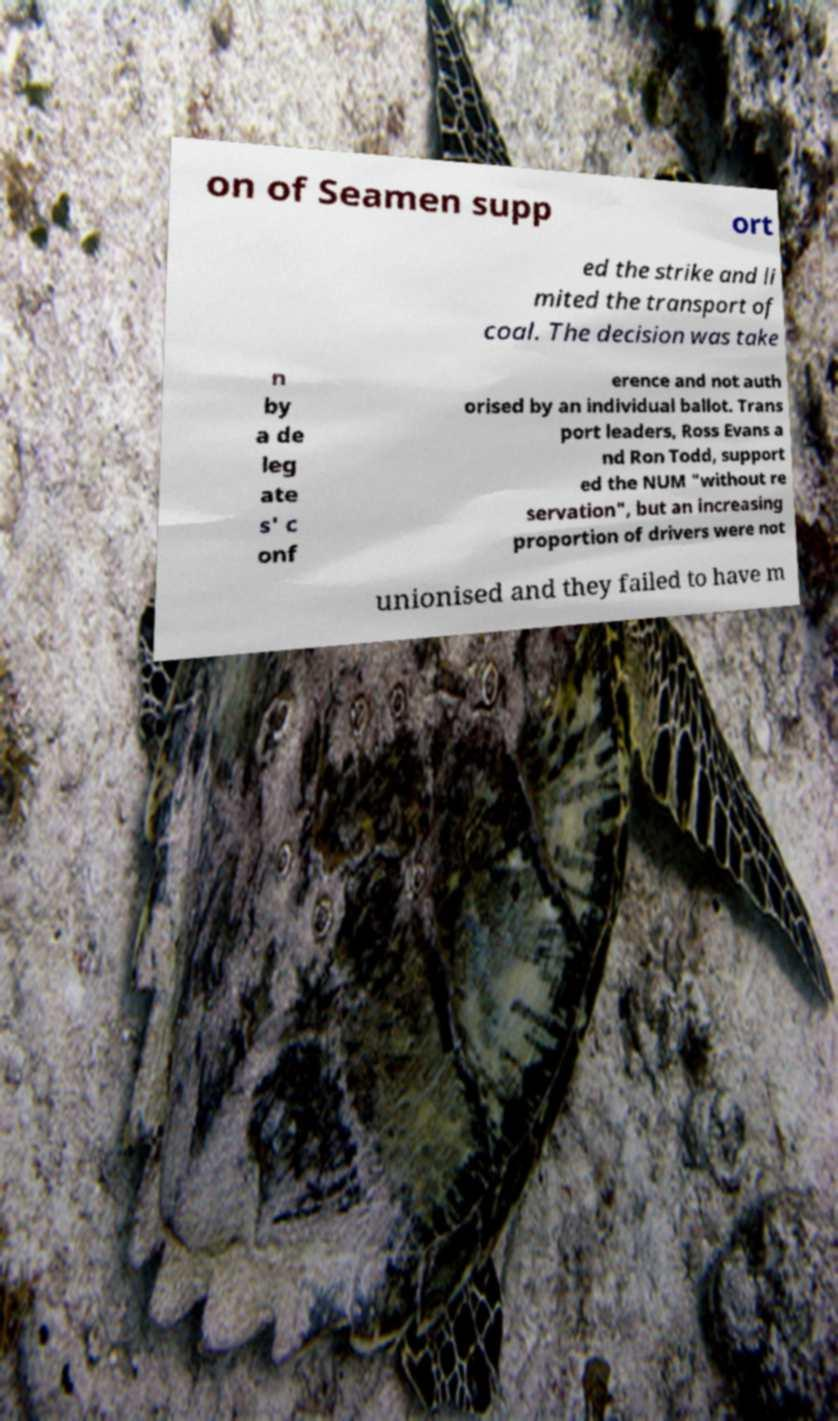For documentation purposes, I need the text within this image transcribed. Could you provide that? on of Seamen supp ort ed the strike and li mited the transport of coal. The decision was take n by a de leg ate s' c onf erence and not auth orised by an individual ballot. Trans port leaders, Ross Evans a nd Ron Todd, support ed the NUM "without re servation", but an increasing proportion of drivers were not unionised and they failed to have m 